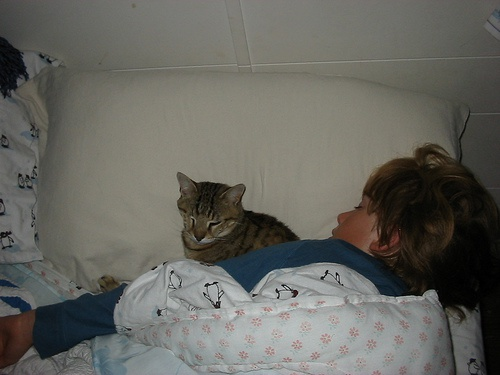Describe the objects in this image and their specific colors. I can see bed in black, gray, and darkgray tones, people in black, maroon, and darkblue tones, and cat in black and gray tones in this image. 